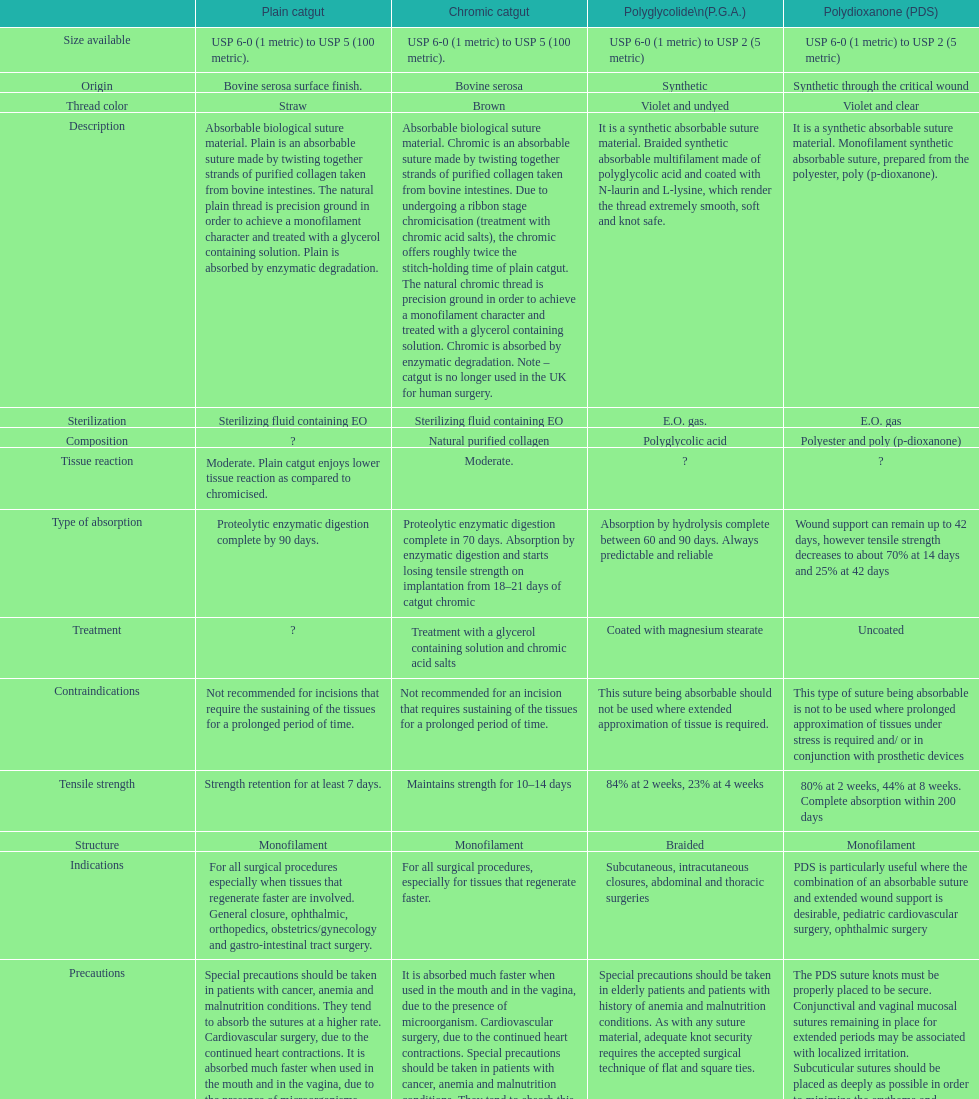What is the structure other than monofilament Braided. 